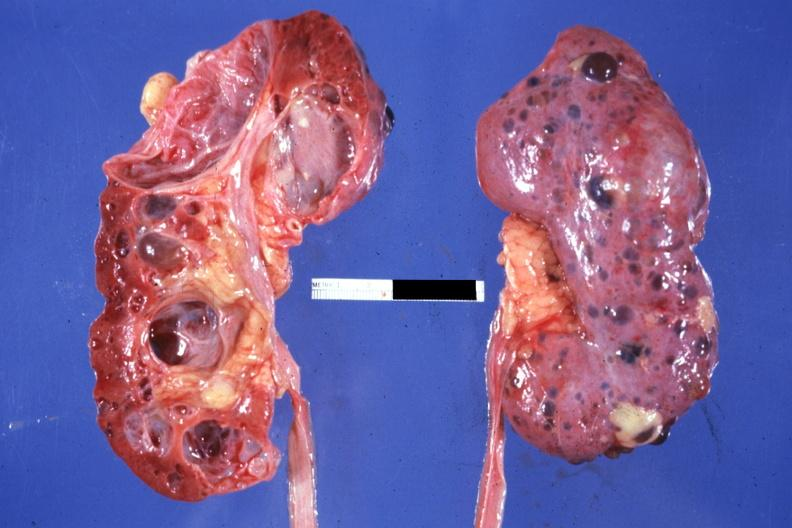does external view of knee at autopsy show nice photo one kidney opened the other from capsular surface many cysts?
Answer the question using a single word or phrase. No 